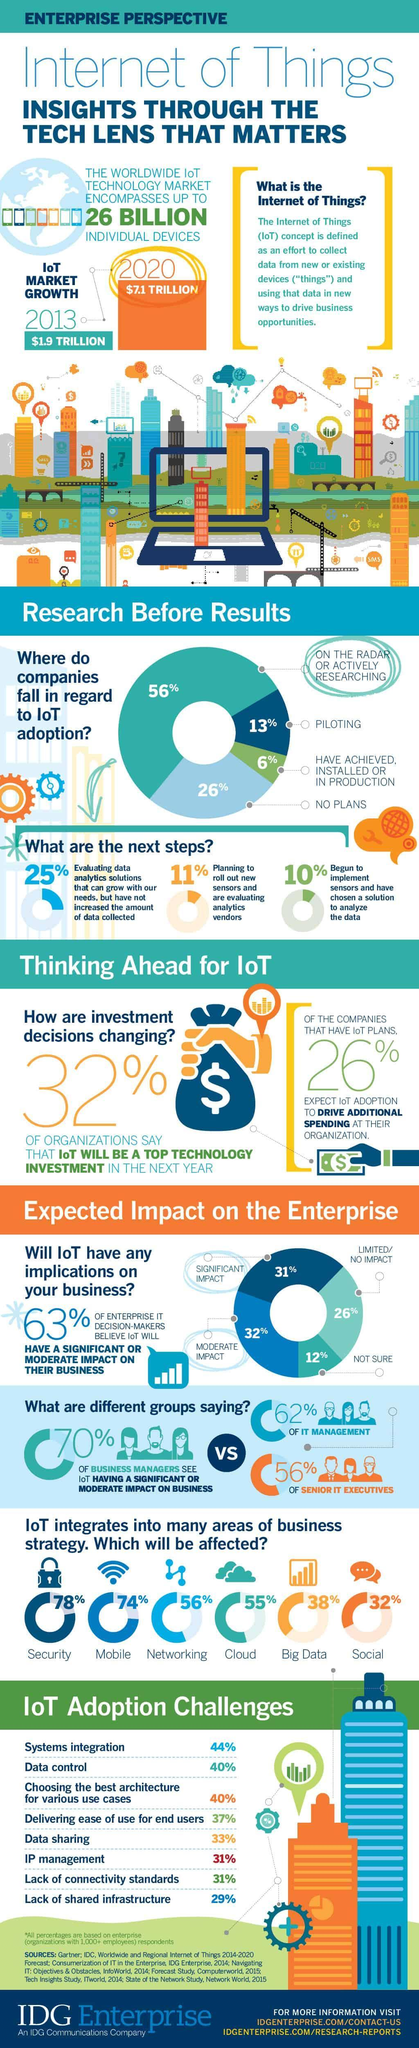What percentage of Big data integrated into IoT?
Answer the question with a short phrase. 38% What percentage of security integrated into IoT? 78% What percentage of mobile not integrated into IoT? 26% 